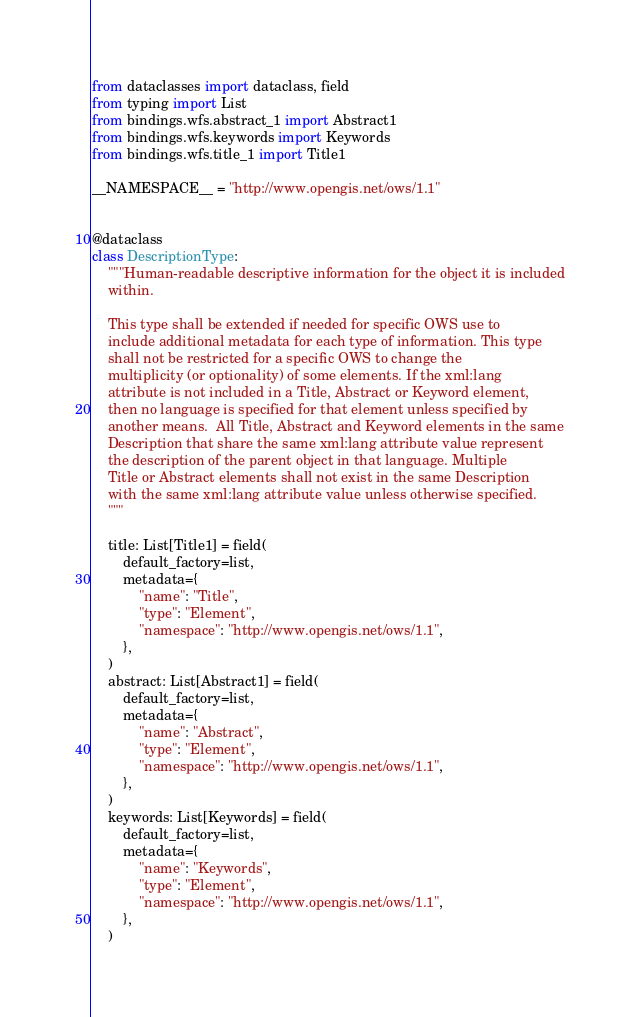Convert code to text. <code><loc_0><loc_0><loc_500><loc_500><_Python_>from dataclasses import dataclass, field
from typing import List
from bindings.wfs.abstract_1 import Abstract1
from bindings.wfs.keywords import Keywords
from bindings.wfs.title_1 import Title1

__NAMESPACE__ = "http://www.opengis.net/ows/1.1"


@dataclass
class DescriptionType:
    """Human-readable descriptive information for the object it is included
    within.

    This type shall be extended if needed for specific OWS use to
    include additional metadata for each type of information. This type
    shall not be restricted for a specific OWS to change the
    multiplicity (or optionality) of some elements. If the xml:lang
    attribute is not included in a Title, Abstract or Keyword element,
    then no language is specified for that element unless specified by
    another means.  All Title, Abstract and Keyword elements in the same
    Description that share the same xml:lang attribute value represent
    the description of the parent object in that language. Multiple
    Title or Abstract elements shall not exist in the same Description
    with the same xml:lang attribute value unless otherwise specified.
    """

    title: List[Title1] = field(
        default_factory=list,
        metadata={
            "name": "Title",
            "type": "Element",
            "namespace": "http://www.opengis.net/ows/1.1",
        },
    )
    abstract: List[Abstract1] = field(
        default_factory=list,
        metadata={
            "name": "Abstract",
            "type": "Element",
            "namespace": "http://www.opengis.net/ows/1.1",
        },
    )
    keywords: List[Keywords] = field(
        default_factory=list,
        metadata={
            "name": "Keywords",
            "type": "Element",
            "namespace": "http://www.opengis.net/ows/1.1",
        },
    )
</code> 